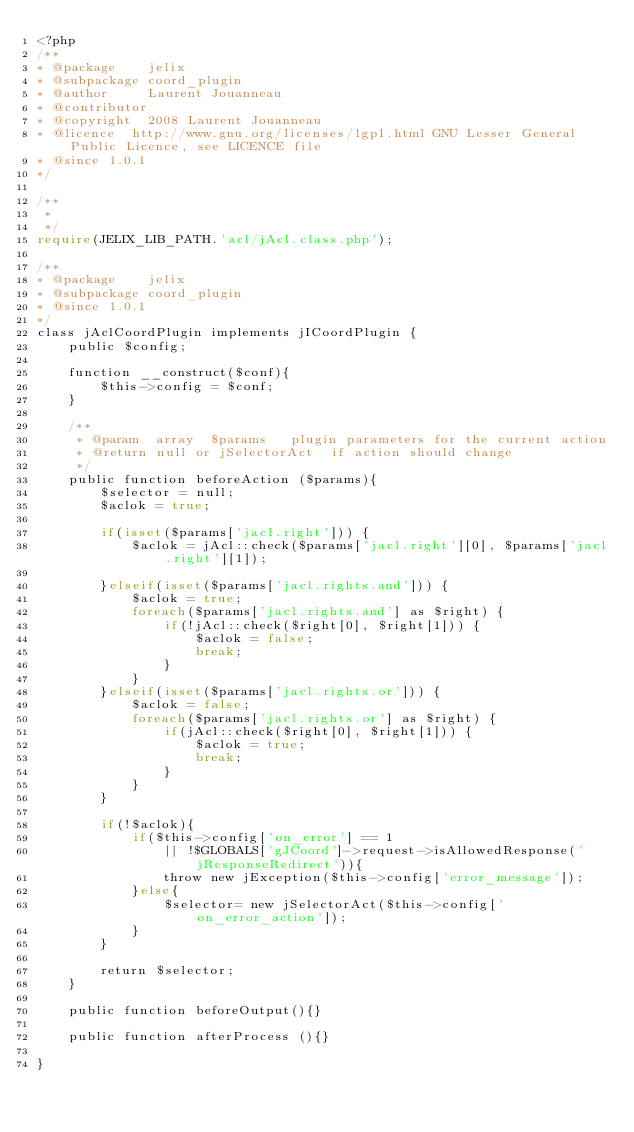<code> <loc_0><loc_0><loc_500><loc_500><_PHP_><?php
/**
* @package    jelix
* @subpackage coord_plugin
* @author     Laurent Jouanneau
* @contributor  
* @copyright  2008 Laurent Jouanneau
* @licence  http://www.gnu.org/licenses/lgpl.html GNU Lesser General Public Licence, see LICENCE file
* @since 1.0.1
*/

/**
 *
 */
require(JELIX_LIB_PATH.'acl/jAcl.class.php');

/**
* @package    jelix
* @subpackage coord_plugin
* @since 1.0.1
*/
class jAclCoordPlugin implements jICoordPlugin {
    public $config;

    function __construct($conf){
        $this->config = $conf;
    }

    /**
     * @param  array  $params   plugin parameters for the current action
     * @return null or jSelectorAct  if action should change
     */
    public function beforeAction ($params){
        $selector = null;
        $aclok = true;

        if(isset($params['jacl.right'])) {
            $aclok = jAcl::check($params['jacl.right'][0], $params['jacl.right'][1]);

        }elseif(isset($params['jacl.rights.and'])) {
            $aclok = true; 
            foreach($params['jacl.rights.and'] as $right) {
                if(!jAcl::check($right[0], $right[1])) {
                    $aclok = false;
                    break;
                }
            }
        }elseif(isset($params['jacl.rights.or'])) {
            $aclok = false;
            foreach($params['jacl.rights.or'] as $right) {
                if(jAcl::check($right[0], $right[1])) {
                    $aclok = true;
                    break;
                }
            }
        }

        if(!$aclok){
            if($this->config['on_error'] == 1 
                || !$GLOBALS['gJCoord']->request->isAllowedResponse('jResponseRedirect')){
                throw new jException($this->config['error_message']);
            }else{
                $selector= new jSelectorAct($this->config['on_error_action']);
            }
        }

        return $selector;
    }

    public function beforeOutput(){}

    public function afterProcess (){}

}

</code> 